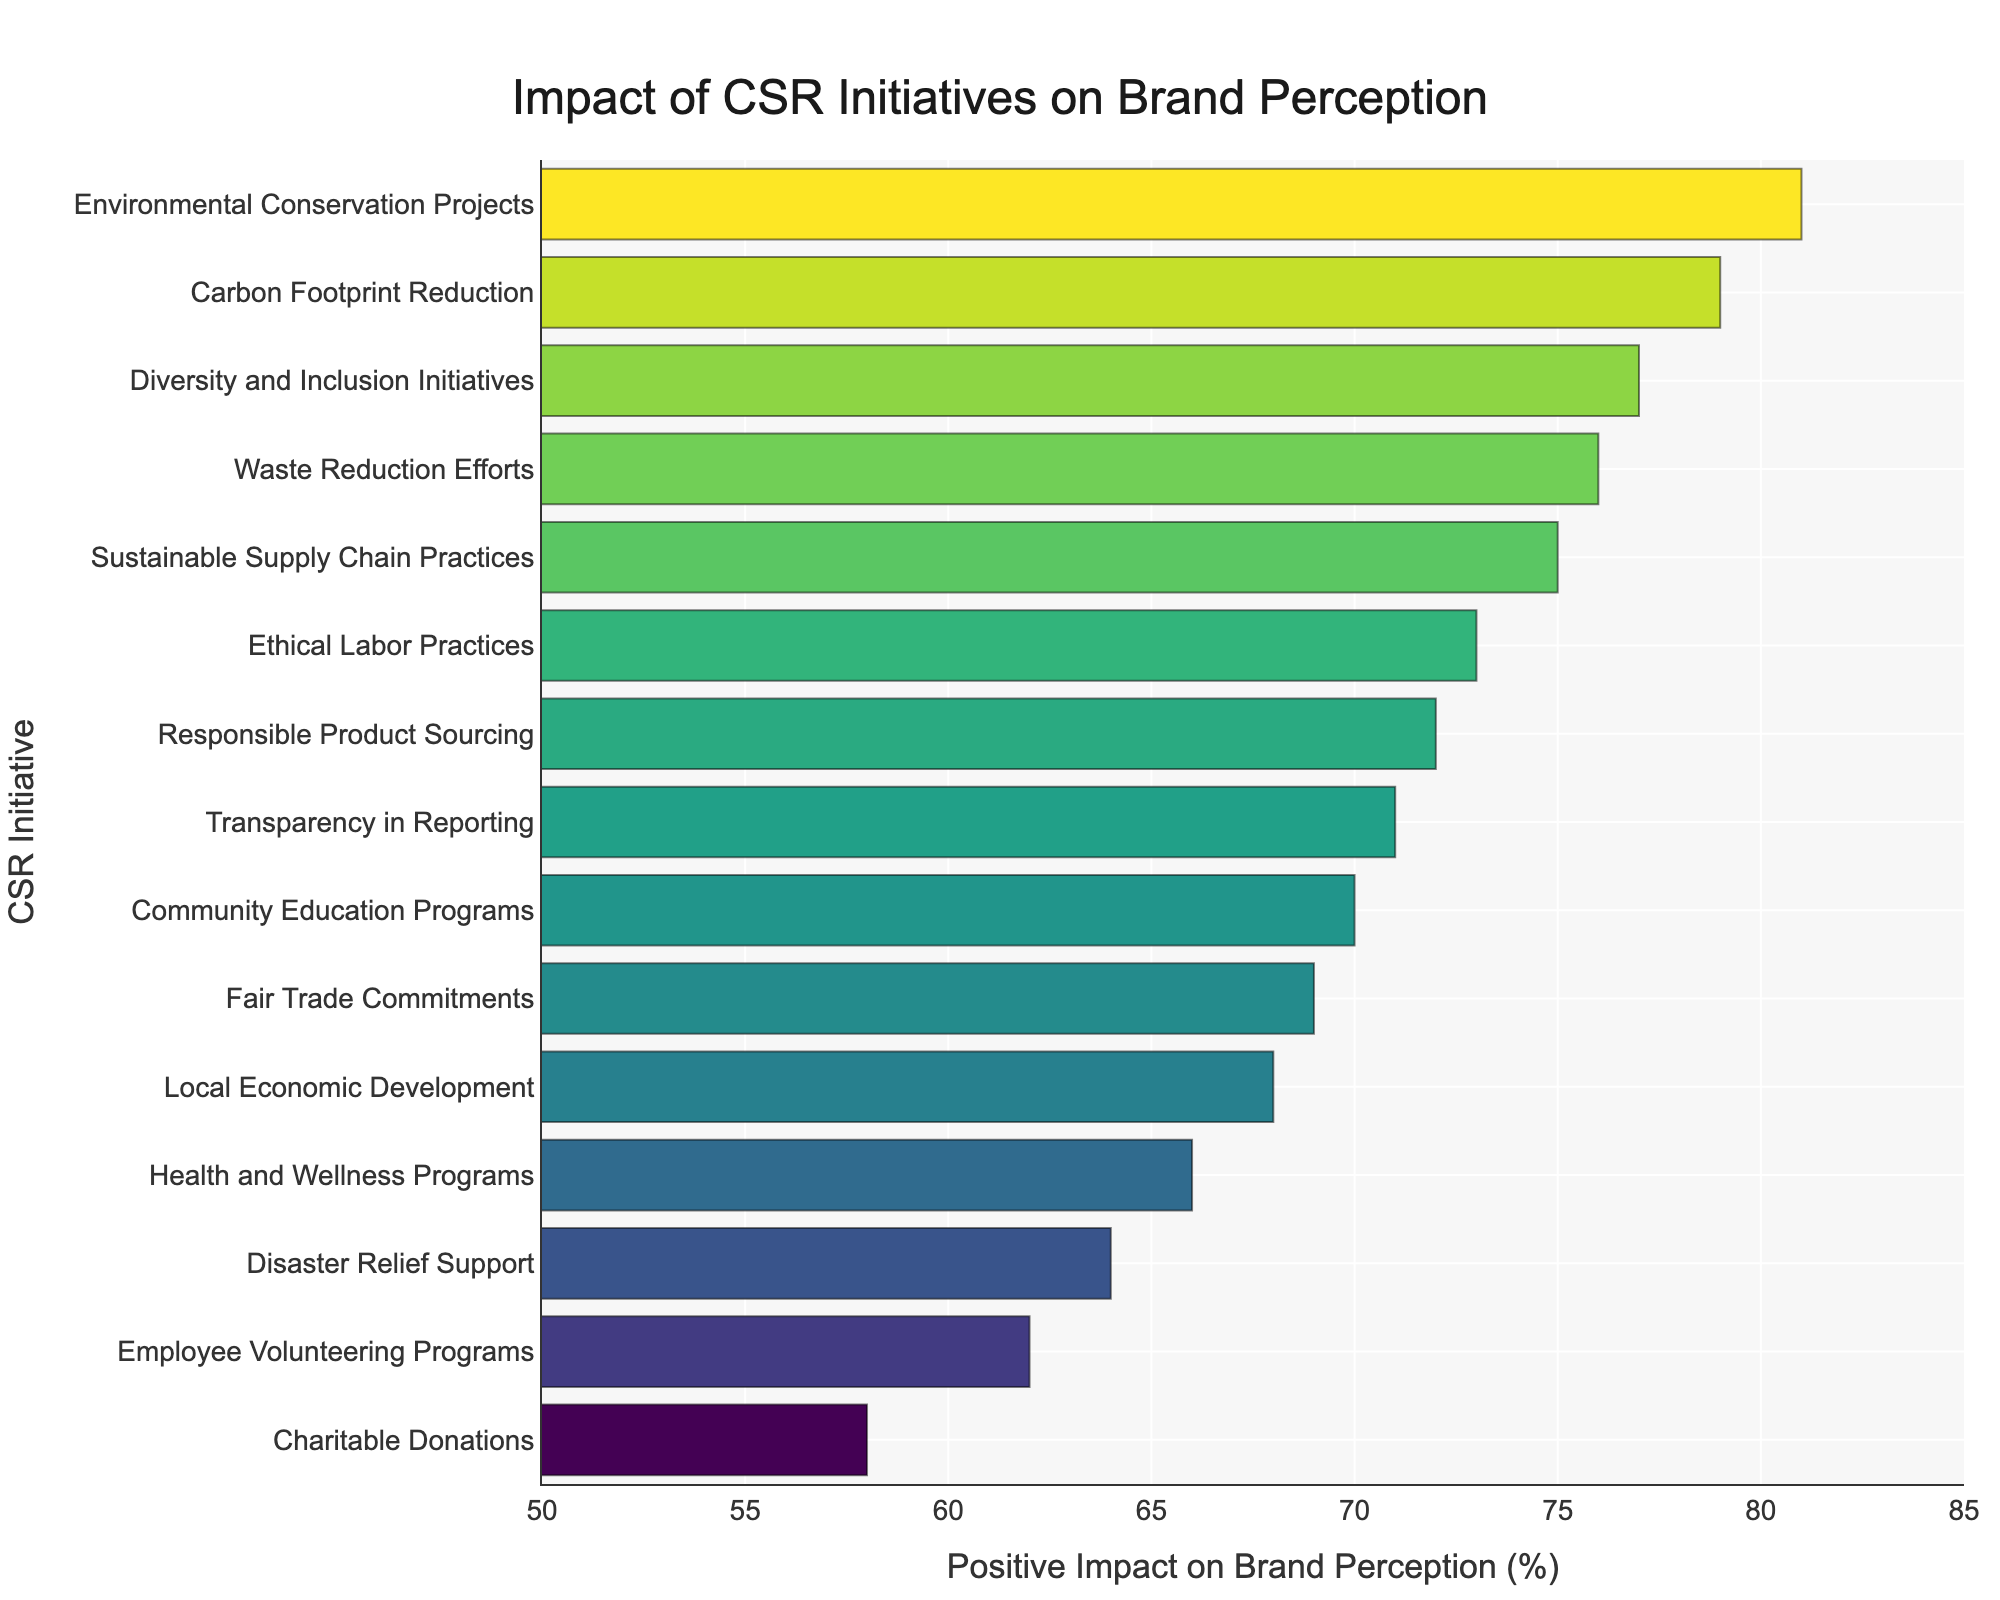Which CSR initiative has the highest positive impact on brand perception? Look for the bar representing the highest value on the x-axis, which is 81%. The corresponding initiative on the y-axis is Environmental Conservation Projects.
Answer: Environmental Conservation Projects Which CSR initiative has the lowest positive impact on brand perception? Look for the bar representing the lowest value on the x-axis, which is 58%. The corresponding initiative on the y-axis is Charitable Donations.
Answer: Charitable Donations How much higher is the impact of Environmental Conservation Projects compared to Charitable Donations? Subtract the impact of Charitable Donations (58%) from the impact of Environmental Conservation Projects (81%). 81% - 58% = 23%.
Answer: 23% What’s the average positive impact on brand perception of Employee Volunteering Programs, Charitable Donations, and Disaster Relief Support? Sum the values of Employee Volunteering Programs (62%), Charitable Donations (58%), and Disaster Relief Support (64%), then divide by 3. (62 + 58 + 64) / 3 = 184 / 3 ≈ 61.33%.
Answer: 61.33% Which initiative has a higher impact on brand perception, Fair Trade Commitments or Carbon Footprint Reduction? Compare the values of Fair Trade Commitments (69%) and Carbon Footprint Reduction (79%). 79% is greater than 69%.
Answer: Carbon Footprint Reduction How many CSR initiatives have a positive impact on brand perception of 70% or higher? Count the bars that have an x-axis value of 70% or higher. From the sorted figure, there are 11 initiatives with 70% or higher.
Answer: 11 What color is used for the highest positive impact value on the chart? Observing the color gradient in the Viridis colorscale, the highest positive impact (81%) is colored with the brightest color on the scale.
Answer: Bright lime green What’s the difference in positive impact on brand perception between Ethical Labor Practices and Community Education Programs? Subtract the positive impact percentage of Community Education Programs (70%) from Ethical Labor Practices (73%). 73 - 70 = 3%.
Answer: 3% Which initiative has a similar impact to Health and Wellness Programs? Find the initiative with a value closest to Health and Wellness Programs (66%). Local Economic Development (68%) is the closest.
Answer: Local Economic Development What is the median value of positive impact on brand perception for the given initiatives? First, list the values in order and find the middle one. Sorted from 58 to 81, the median value is the 8th value in a list of 15, which is Responsible Product Sourcing (72%).
Answer: 72% 